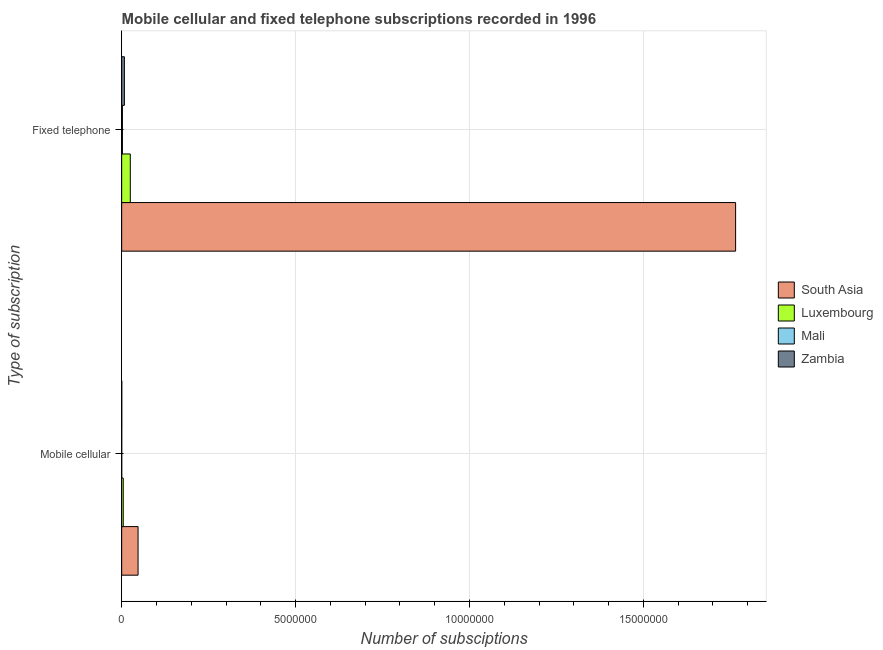How many different coloured bars are there?
Offer a terse response. 4. Are the number of bars on each tick of the Y-axis equal?
Offer a terse response. Yes. What is the label of the 2nd group of bars from the top?
Make the answer very short. Mobile cellular. What is the number of fixed telephone subscriptions in Luxembourg?
Your answer should be compact. 2.48e+05. Across all countries, what is the maximum number of fixed telephone subscriptions?
Make the answer very short. 1.77e+07. Across all countries, what is the minimum number of mobile cellular subscriptions?
Keep it short and to the point. 1187. In which country was the number of fixed telephone subscriptions minimum?
Your answer should be very brief. Mali. What is the total number of mobile cellular subscriptions in the graph?
Provide a short and direct response. 5.20e+05. What is the difference between the number of fixed telephone subscriptions in Mali and that in Luxembourg?
Offer a terse response. -2.27e+05. What is the difference between the number of mobile cellular subscriptions in Luxembourg and the number of fixed telephone subscriptions in Mali?
Ensure brevity in your answer.  2.37e+04. What is the average number of fixed telephone subscriptions per country?
Offer a very short reply. 4.50e+06. What is the difference between the number of fixed telephone subscriptions and number of mobile cellular subscriptions in Luxembourg?
Provide a succinct answer. 2.03e+05. What is the ratio of the number of fixed telephone subscriptions in Luxembourg to that in South Asia?
Ensure brevity in your answer.  0.01. Is the number of mobile cellular subscriptions in Luxembourg less than that in Zambia?
Provide a short and direct response. No. In how many countries, is the number of mobile cellular subscriptions greater than the average number of mobile cellular subscriptions taken over all countries?
Your response must be concise. 1. What does the 2nd bar from the top in Fixed telephone represents?
Keep it short and to the point. Mali. What does the 1st bar from the bottom in Mobile cellular represents?
Provide a short and direct response. South Asia. How many bars are there?
Your answer should be very brief. 8. Are all the bars in the graph horizontal?
Keep it short and to the point. Yes. How many countries are there in the graph?
Give a very brief answer. 4. Are the values on the major ticks of X-axis written in scientific E-notation?
Keep it short and to the point. No. Does the graph contain any zero values?
Ensure brevity in your answer.  No. Does the graph contain grids?
Make the answer very short. Yes. How many legend labels are there?
Provide a succinct answer. 4. How are the legend labels stacked?
Offer a terse response. Vertical. What is the title of the graph?
Provide a succinct answer. Mobile cellular and fixed telephone subscriptions recorded in 1996. Does "Iceland" appear as one of the legend labels in the graph?
Provide a short and direct response. No. What is the label or title of the X-axis?
Keep it short and to the point. Number of subsciptions. What is the label or title of the Y-axis?
Give a very brief answer. Type of subscription. What is the Number of subsciptions of South Asia in Mobile cellular?
Offer a very short reply. 4.71e+05. What is the Number of subsciptions in Luxembourg in Mobile cellular?
Your response must be concise. 4.50e+04. What is the Number of subsciptions of Mali in Mobile cellular?
Give a very brief answer. 1187. What is the Number of subsciptions in Zambia in Mobile cellular?
Give a very brief answer. 2721. What is the Number of subsciptions in South Asia in Fixed telephone?
Provide a short and direct response. 1.77e+07. What is the Number of subsciptions in Luxembourg in Fixed telephone?
Keep it short and to the point. 2.48e+05. What is the Number of subsciptions in Mali in Fixed telephone?
Your answer should be very brief. 2.13e+04. What is the Number of subsciptions of Zambia in Fixed telephone?
Your answer should be compact. 7.79e+04. Across all Type of subscription, what is the maximum Number of subsciptions of South Asia?
Your answer should be very brief. 1.77e+07. Across all Type of subscription, what is the maximum Number of subsciptions of Luxembourg?
Your response must be concise. 2.48e+05. Across all Type of subscription, what is the maximum Number of subsciptions of Mali?
Your answer should be compact. 2.13e+04. Across all Type of subscription, what is the maximum Number of subsciptions of Zambia?
Offer a terse response. 7.79e+04. Across all Type of subscription, what is the minimum Number of subsciptions in South Asia?
Your answer should be very brief. 4.71e+05. Across all Type of subscription, what is the minimum Number of subsciptions of Luxembourg?
Offer a very short reply. 4.50e+04. Across all Type of subscription, what is the minimum Number of subsciptions in Mali?
Make the answer very short. 1187. Across all Type of subscription, what is the minimum Number of subsciptions in Zambia?
Offer a terse response. 2721. What is the total Number of subsciptions in South Asia in the graph?
Provide a succinct answer. 1.81e+07. What is the total Number of subsciptions in Luxembourg in the graph?
Offer a very short reply. 2.93e+05. What is the total Number of subsciptions in Mali in the graph?
Your response must be concise. 2.25e+04. What is the total Number of subsciptions of Zambia in the graph?
Your response must be concise. 8.07e+04. What is the difference between the Number of subsciptions in South Asia in Mobile cellular and that in Fixed telephone?
Keep it short and to the point. -1.72e+07. What is the difference between the Number of subsciptions in Luxembourg in Mobile cellular and that in Fixed telephone?
Your answer should be very brief. -2.03e+05. What is the difference between the Number of subsciptions of Mali in Mobile cellular and that in Fixed telephone?
Provide a short and direct response. -2.01e+04. What is the difference between the Number of subsciptions of Zambia in Mobile cellular and that in Fixed telephone?
Provide a short and direct response. -7.52e+04. What is the difference between the Number of subsciptions of South Asia in Mobile cellular and the Number of subsciptions of Luxembourg in Fixed telephone?
Keep it short and to the point. 2.23e+05. What is the difference between the Number of subsciptions in South Asia in Mobile cellular and the Number of subsciptions in Mali in Fixed telephone?
Provide a short and direct response. 4.50e+05. What is the difference between the Number of subsciptions in South Asia in Mobile cellular and the Number of subsciptions in Zambia in Fixed telephone?
Your answer should be very brief. 3.93e+05. What is the difference between the Number of subsciptions of Luxembourg in Mobile cellular and the Number of subsciptions of Mali in Fixed telephone?
Your answer should be compact. 2.37e+04. What is the difference between the Number of subsciptions of Luxembourg in Mobile cellular and the Number of subsciptions of Zambia in Fixed telephone?
Your response must be concise. -3.29e+04. What is the difference between the Number of subsciptions in Mali in Mobile cellular and the Number of subsciptions in Zambia in Fixed telephone?
Your answer should be very brief. -7.67e+04. What is the average Number of subsciptions in South Asia per Type of subscription?
Provide a short and direct response. 9.06e+06. What is the average Number of subsciptions in Luxembourg per Type of subscription?
Provide a short and direct response. 1.47e+05. What is the average Number of subsciptions of Mali per Type of subscription?
Offer a terse response. 1.12e+04. What is the average Number of subsciptions in Zambia per Type of subscription?
Your response must be concise. 4.03e+04. What is the difference between the Number of subsciptions in South Asia and Number of subsciptions in Luxembourg in Mobile cellular?
Provide a short and direct response. 4.26e+05. What is the difference between the Number of subsciptions in South Asia and Number of subsciptions in Mali in Mobile cellular?
Your response must be concise. 4.70e+05. What is the difference between the Number of subsciptions of South Asia and Number of subsciptions of Zambia in Mobile cellular?
Offer a terse response. 4.68e+05. What is the difference between the Number of subsciptions of Luxembourg and Number of subsciptions of Mali in Mobile cellular?
Give a very brief answer. 4.38e+04. What is the difference between the Number of subsciptions of Luxembourg and Number of subsciptions of Zambia in Mobile cellular?
Your answer should be compact. 4.23e+04. What is the difference between the Number of subsciptions in Mali and Number of subsciptions in Zambia in Mobile cellular?
Offer a very short reply. -1534. What is the difference between the Number of subsciptions of South Asia and Number of subsciptions of Luxembourg in Fixed telephone?
Keep it short and to the point. 1.74e+07. What is the difference between the Number of subsciptions in South Asia and Number of subsciptions in Mali in Fixed telephone?
Offer a terse response. 1.76e+07. What is the difference between the Number of subsciptions in South Asia and Number of subsciptions in Zambia in Fixed telephone?
Your answer should be very brief. 1.76e+07. What is the difference between the Number of subsciptions of Luxembourg and Number of subsciptions of Mali in Fixed telephone?
Offer a very short reply. 2.27e+05. What is the difference between the Number of subsciptions of Luxembourg and Number of subsciptions of Zambia in Fixed telephone?
Ensure brevity in your answer.  1.70e+05. What is the difference between the Number of subsciptions of Mali and Number of subsciptions of Zambia in Fixed telephone?
Offer a terse response. -5.66e+04. What is the ratio of the Number of subsciptions of South Asia in Mobile cellular to that in Fixed telephone?
Your response must be concise. 0.03. What is the ratio of the Number of subsciptions of Luxembourg in Mobile cellular to that in Fixed telephone?
Your answer should be very brief. 0.18. What is the ratio of the Number of subsciptions in Mali in Mobile cellular to that in Fixed telephone?
Make the answer very short. 0.06. What is the ratio of the Number of subsciptions in Zambia in Mobile cellular to that in Fixed telephone?
Keep it short and to the point. 0.03. What is the difference between the highest and the second highest Number of subsciptions of South Asia?
Your answer should be compact. 1.72e+07. What is the difference between the highest and the second highest Number of subsciptions of Luxembourg?
Your answer should be very brief. 2.03e+05. What is the difference between the highest and the second highest Number of subsciptions in Mali?
Provide a short and direct response. 2.01e+04. What is the difference between the highest and the second highest Number of subsciptions in Zambia?
Offer a terse response. 7.52e+04. What is the difference between the highest and the lowest Number of subsciptions in South Asia?
Your response must be concise. 1.72e+07. What is the difference between the highest and the lowest Number of subsciptions of Luxembourg?
Offer a very short reply. 2.03e+05. What is the difference between the highest and the lowest Number of subsciptions of Mali?
Give a very brief answer. 2.01e+04. What is the difference between the highest and the lowest Number of subsciptions of Zambia?
Ensure brevity in your answer.  7.52e+04. 